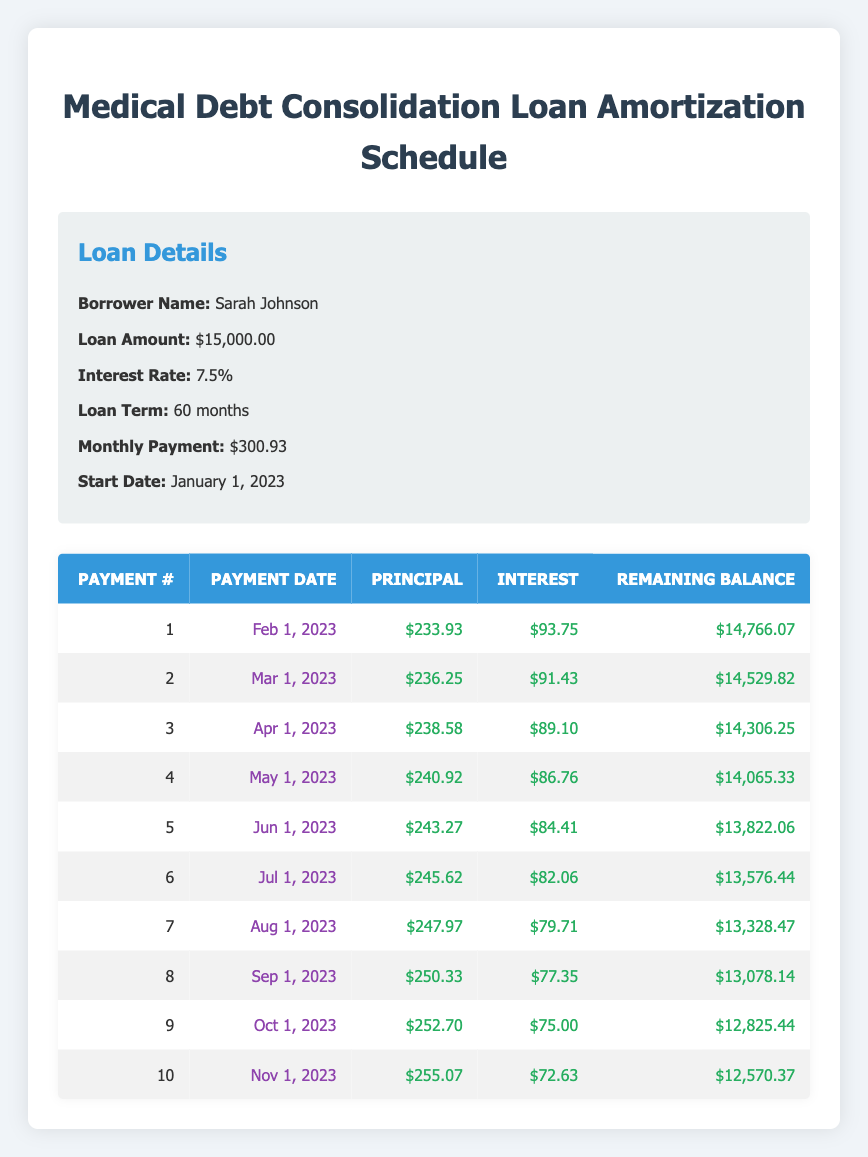What is the total loan amount taken by Sarah Johnson? The loan details specify that the loan amount is $15,000.00.
Answer: 15000.00 What was the monthly payment for the loan? According to the loan details, the monthly payment specified is $300.93.
Answer: 300.93 On what date was the first payment made? The schedule states that the first payment date is February 1, 2023.
Answer: February 1, 2023 How much of the principal was paid in the second payment? Referring to the amortization schedule, the principal payment for the second payment is $236.25.
Answer: 236.25 Is the interest payment for the tenth payment greater than the interest payment for the first payment? According to the amortization schedule, the interest payment for the tenth payment is $72.63 and for the first payment is $93.75. Since $72.63 is less than $93.75, the statement is false.
Answer: No What is the remaining balance after the fifth payment? By looking at the amortization schedule, the remaining balance after the fifth payment (on June 1, 2023) is $13,822.06.
Answer: 13822.06 What is the total principal paid off after the first three payments? The principal payments after the first three payments are as follows: $233.93 (first) + $236.25 (second) + $238.58 (third) = $708.76.
Answer: 708.76 What is the difference in the interest payment between the first and eighth payments? The interest payment for the first payment is $93.75, and for the eighth payment it is $77.35. The difference is $93.75 - $77.35 = $16.40.
Answer: 16.40 What was the amount of the principal payment for the seventh installment? The amortization schedule indicates that the principal payment for the seventh installment is $247.97.
Answer: 247.97 After how many months will the loan be fully paid off? The loan term specified is 60 months, which means the loan will be fully paid off after 60 months.
Answer: 60 months 